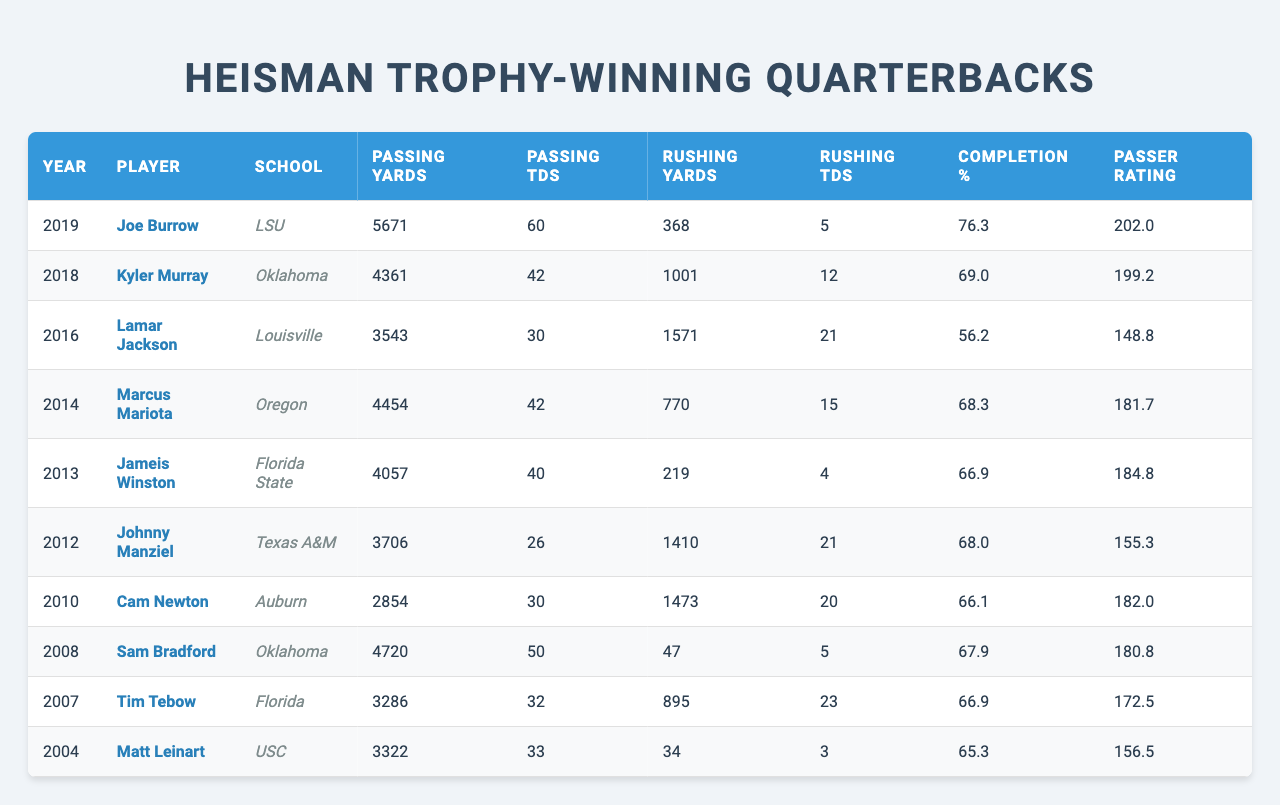What year did Joe Burrow win the Heisman Trophy? Joe Burrow's name appears in the 2019 row of the table, which corresponds to the year he won the Heisman Trophy.
Answer: 2019 Which quarterback had the highest passing yards in a single season? Joe Burrow has the highest passing yards listed, with 5671 yards in 2019, more than any other quarterback in the table.
Answer: 5671 yards How many rushing touchdowns did Kyler Murray score? By looking at the row for Kyler Murray in 2018, we see that he scored 12 rushing touchdowns.
Answer: 12 What is the completion percentage of Marcus Mariota? The completion percentage for Marcus Mariota is found in the row for 2014, which shows a percentage of 68.3%.
Answer: 68.3% Who had more rushing yards, Lamar Jackson or Johnny Manziel? Lamar Jackson, in the 2016 row, has 1571 rushing yards, while Johnny Manziel, in the 2012 row, has 1410 rushing yards. Comparing these values shows that Lamar Jackson had more.
Answer: Lamar Jackson What is the average passer rating of the quarterbacks listed? To find the average passer rating, sum up all passer ratings: 202 + 199.2 + 148.8 + 181.7 + 184.8 + 155.3 + 182 + 180.8 + 172.5 + 156.5 = 1863.1. There are 10 players, so the average is 1863.1/10 = 186.31.
Answer: 186.31 Did any quarterback score less than 20 rushing touchdowns? Reviewing the rushing touchdowns column, we note that several players scored below 20: Cam Newton (20), Jameis Winston (4), and the rest, thus confirming that there are quarterbacks with less than 20 rushing touchdowns.
Answer: Yes Which player had the lowest passer rating? The lowest passer rating is found in Lamar Jackson's row, where his passer rating is 148.8, the least among all listed quarterbacks.
Answer: 148.8 How many total passing touchdowns did Joe Burrow and Kyler Murray score combined? Joe Burrow scored 60 passing touchdowns in 2019 and Kyler Murray scored 42 in 2018. Adding these together gives 60 + 42 = 102.
Answer: 102 Which player rushed for more yards than he passed for? Analyzing the stats, Lamar Jackson had 1571 rushing yards and 3543 passing yards, meaning he passed for more yards. Meanwhile, both Johnny Manziel (1410 rushing to 3706 passing) and Tim Tebow (895 rushing to 3286 passing) passed for more than they rushed. Therefore, no player rushed more than they passed.
Answer: No 